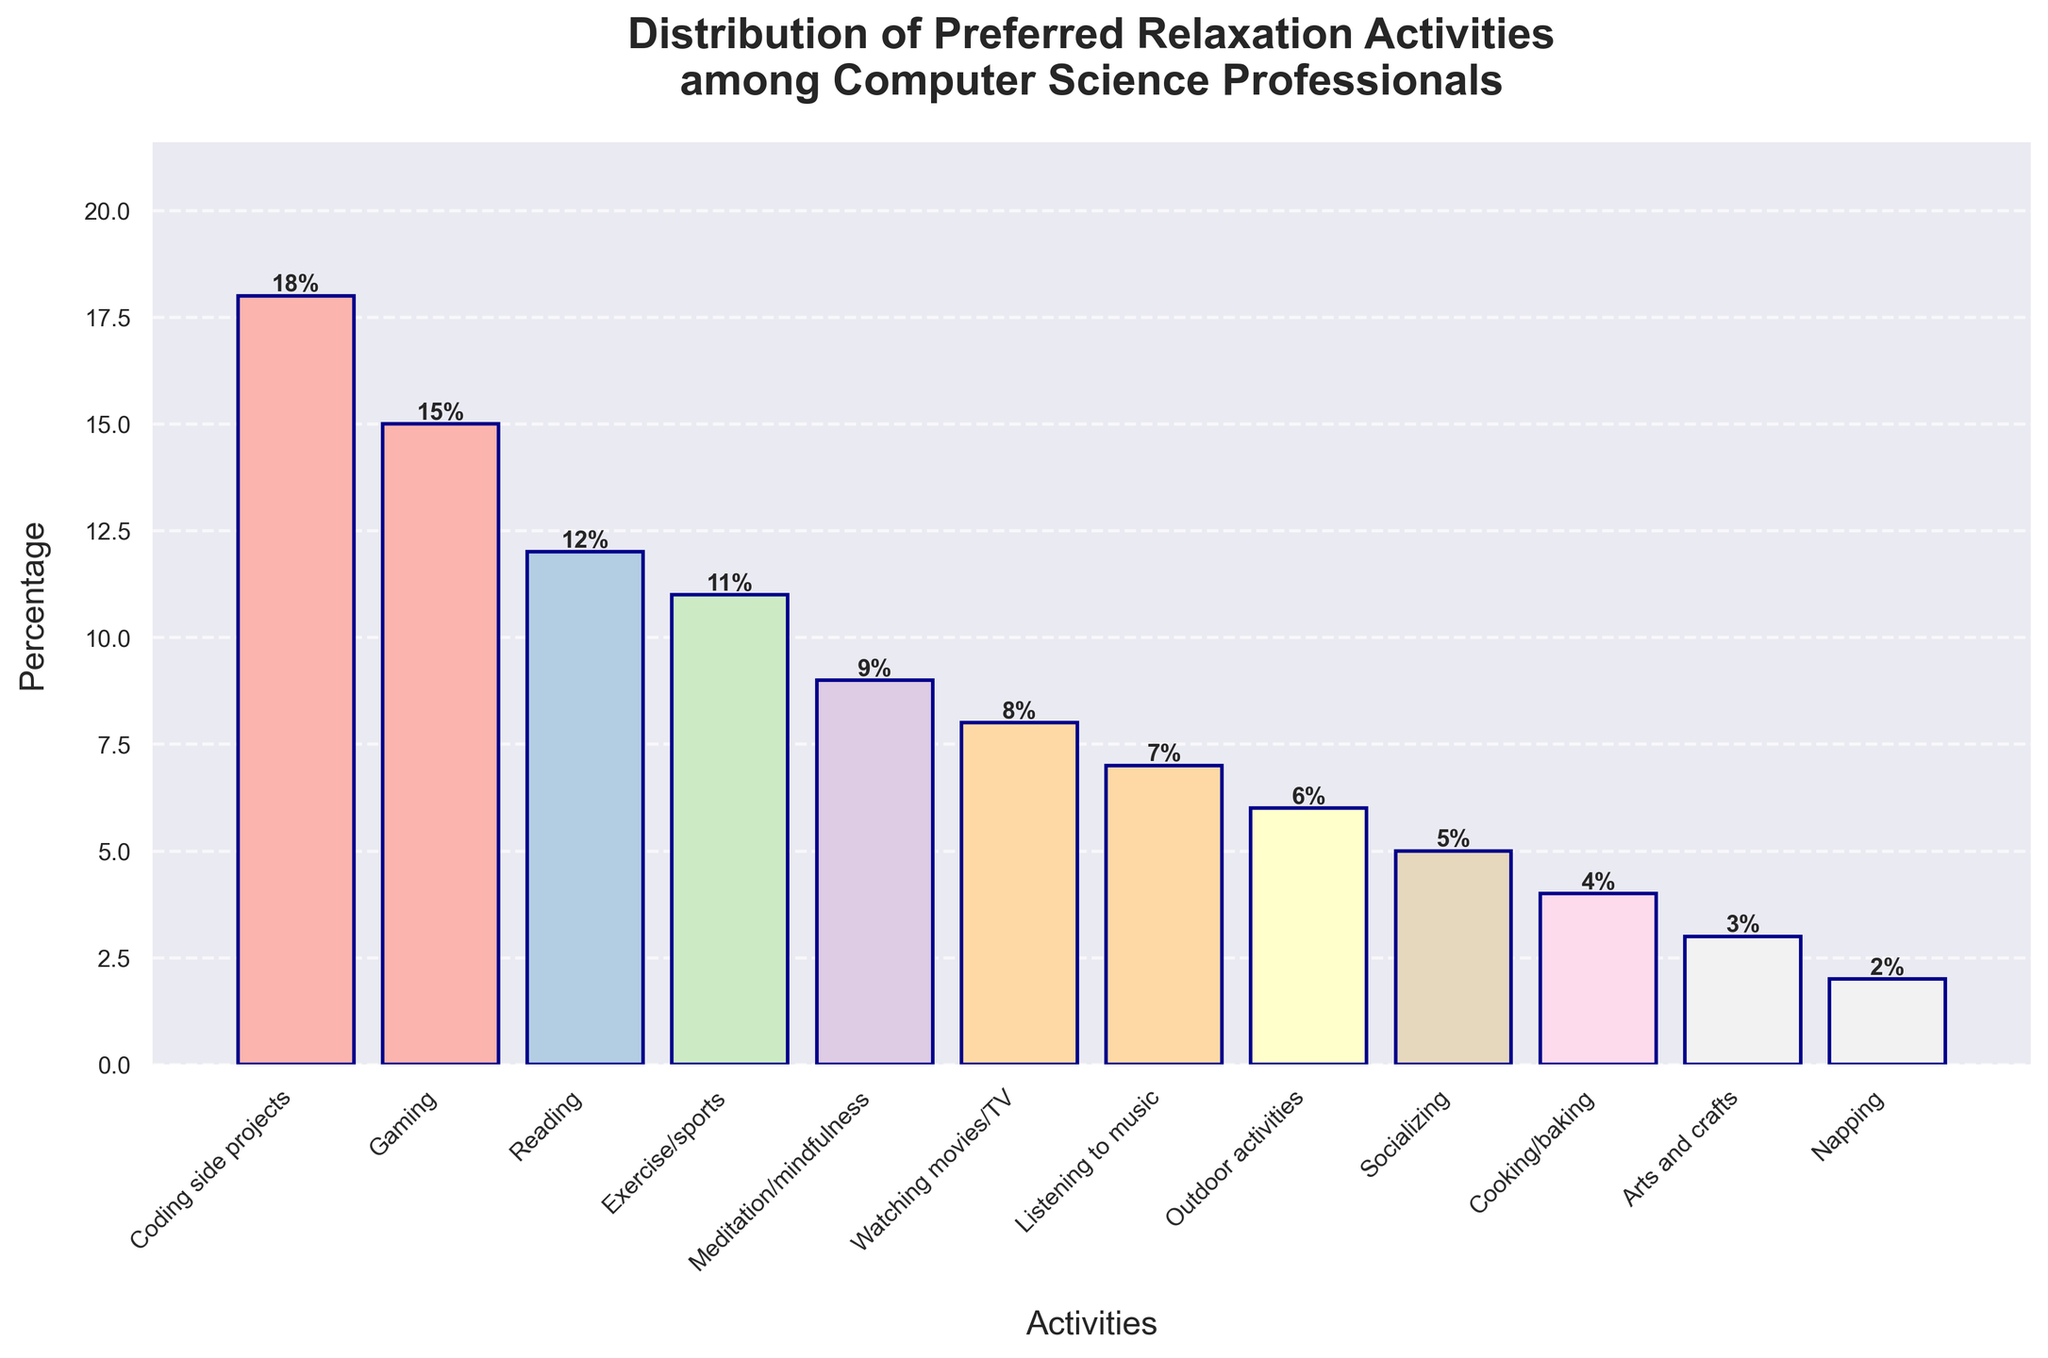What activity holds the highest percentage? The activity with the highest percentage can be seen as the tallest bar on the graph. The tallest bar is "Coding side projects," which reaches to 18%.
Answer: Coding side projects How much higher is "Coding side projects" compared to "Reading"? To determine the difference in percentage between these two activities, subtract the percentage of "Reading" from "Coding side projects." That is, 18% - 12% = 6%.
Answer: 6% Which activity has a percentage closest to "Exercise/sports"? By observing the heights of the bars, the percentage of "Exercise/sports" is 11%. The activities with percentages close to this are "Reading" at 12% and "Meditation/mindfulness" at 9%.
Answer: Reading and Meditation/mindfulness What is the total percentage of activities related to physical wellness (Exercise/sports, Meditation/mindfulness, Outdoor activities)? Sum the percentages for "Exercise/sports" (11%), "Meditation/mindfulness" (9%), and "Outdoor activities" (6%). The total is 11% + 9% + 6% = 26%.
Answer: 26% Is there more interest in "Listening to music" or "Watching movies/TV"? Compare the heights of the bars for these two activities. "Listening to music" is at 7%, and "Watching movies/TV" is at 8%. Since 8% is greater than 7%, "Watching movies/TV" has more interest.
Answer: Watching movies/TV Which activities have a percentage of less than 5%? Look for activities with bars reaching below the 5% mark. The activities are "Cooking/baking" (4%), "Arts and crafts" (3%), and "Napping" (2%).
Answer: Cooking/baking, Arts and crafts, and Napping What is the combined percentage of the least preferred activities (percentage less than 5%)? Sum the percentages for "Cooking/baking" (4%), "Arts and crafts" (3%), and "Napping" (2%). The combined percentage is 4% + 3% + 2% = 9%.
Answer: 9% Rank the top three activities in terms of percentage. Identify the three tallest bars and list their activities in descending order of height. The top three activities are "Coding side projects" (18%), "Gaming" (15%), and "Reading" (12%).
Answer: 1. Coding side projects, 2. Gaming, 3. Reading How does the percentage of "Socializing" compare to "Gaming"? Compare the heights of these bars. "Socializing" has a percentage of 5%, while "Gaming" has 15%. "Gaming" is higher by 15% - 5% = 10%.
Answer: Gaming is higher by 10% If an employer wants to support the top 50% of relaxation activities by percentage, which activities should they focus on? Calculate the cumulative percentage until the sum exceeds 50%. The sum up to "Gaming" (18% + 15% = 33%) and adding "Reading" (33% + 12% = 45%) does not reach 50%, but with "Exercise/sports" (45% + 11% = 56%), it surpasses 50%. So focus on "Coding side projects," "Gaming," "Reading," and "Exercise/sports."
Answer: Coding side projects, Gaming, Reading, Exercise/sports 